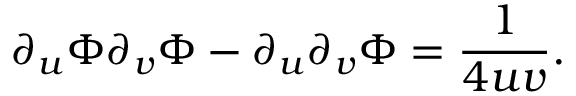Convert formula to latex. <formula><loc_0><loc_0><loc_500><loc_500>\partial _ { u } \Phi \partial _ { v } \Phi - \partial _ { u } \partial _ { v } \Phi = \frac { 1 } { 4 u v } .</formula> 